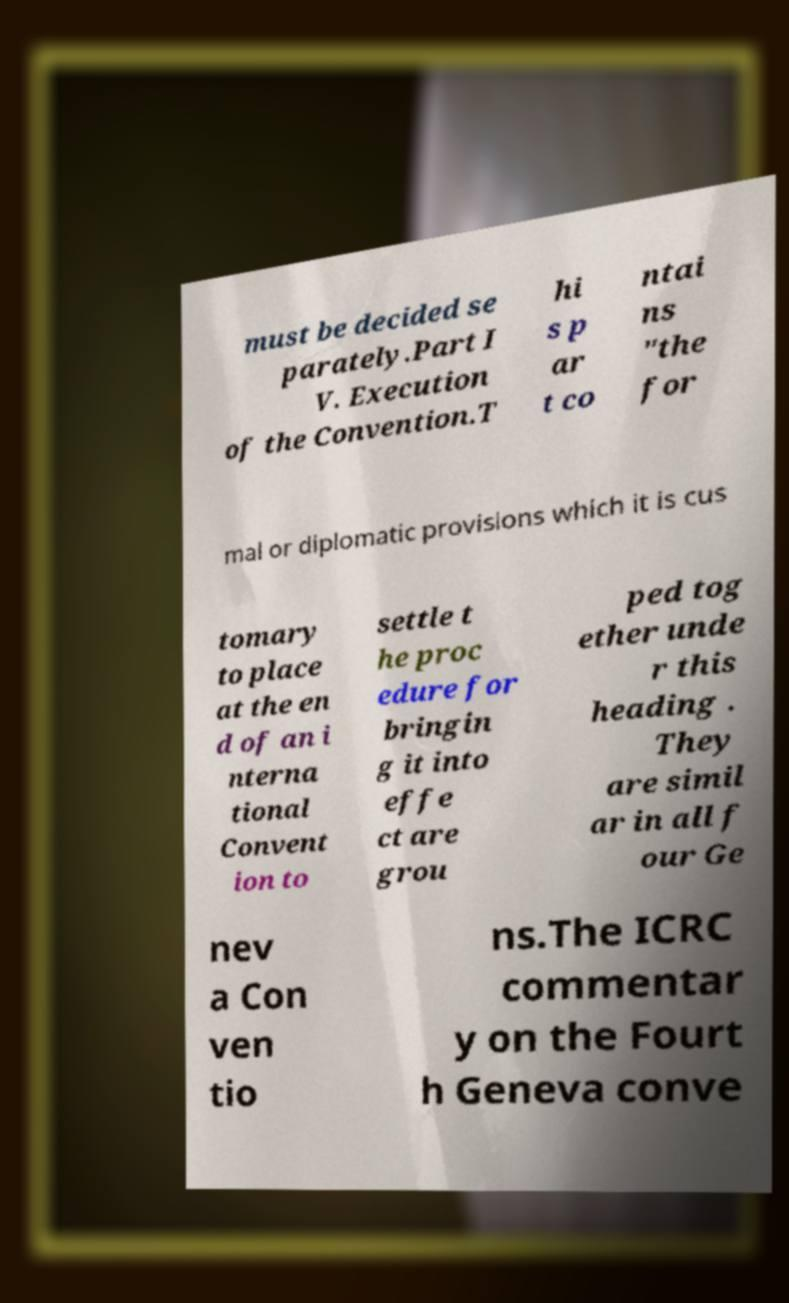I need the written content from this picture converted into text. Can you do that? must be decided se parately.Part I V. Execution of the Convention.T hi s p ar t co ntai ns "the for mal or diplomatic provisions which it is cus tomary to place at the en d of an i nterna tional Convent ion to settle t he proc edure for bringin g it into effe ct are grou ped tog ether unde r this heading . They are simil ar in all f our Ge nev a Con ven tio ns.The ICRC commentar y on the Fourt h Geneva conve 